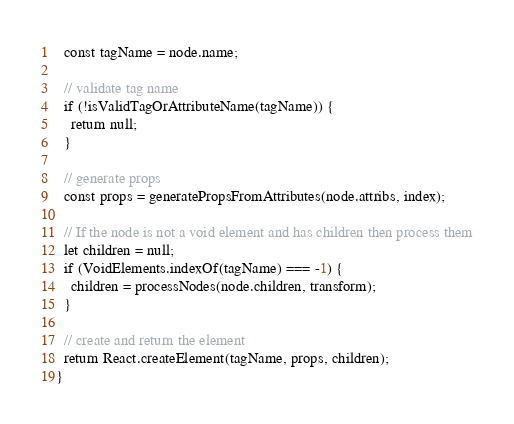<code> <loc_0><loc_0><loc_500><loc_500><_JavaScript_>
  const tagName = node.name;

  // validate tag name
  if (!isValidTagOrAttributeName(tagName)) {
    return null;
  }

  // generate props
  const props = generatePropsFromAttributes(node.attribs, index);

  // If the node is not a void element and has children then process them
  let children = null;
  if (VoidElements.indexOf(tagName) === -1) {
    children = processNodes(node.children, transform);
  }

  // create and return the element
  return React.createElement(tagName, props, children);
}
</code> 